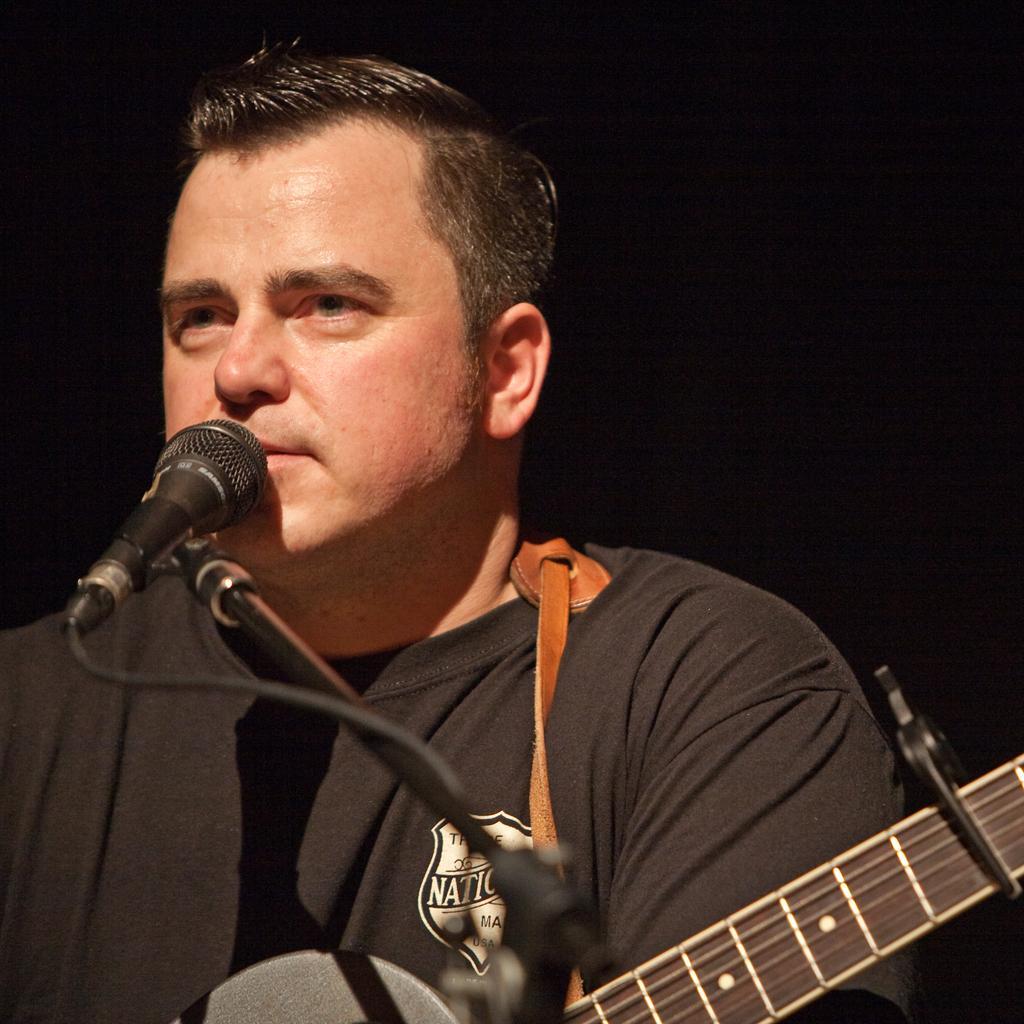Could you give a brief overview of what you see in this image? a person is playing guitar and a microphone is present in front of him. 